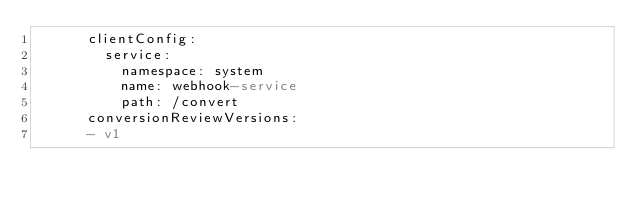<code> <loc_0><loc_0><loc_500><loc_500><_YAML_>      clientConfig:
        service:
          namespace: system
          name: webhook-service
          path: /convert
      conversionReviewVersions:
      - v1
</code> 